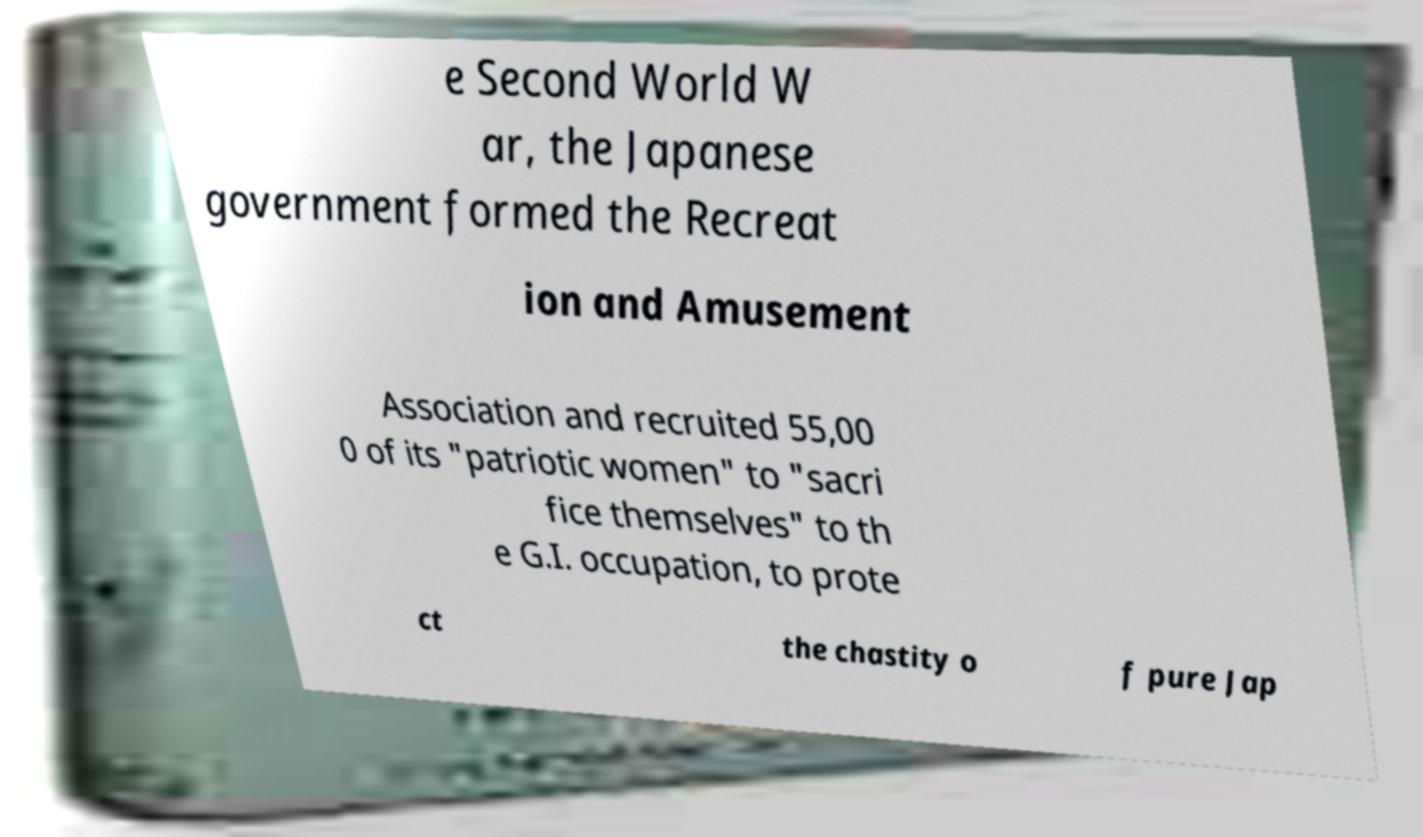Can you read and provide the text displayed in the image?This photo seems to have some interesting text. Can you extract and type it out for me? e Second World W ar, the Japanese government formed the Recreat ion and Amusement Association and recruited 55,00 0 of its "patriotic women" to "sacri fice themselves" to th e G.I. occupation, to prote ct the chastity o f pure Jap 